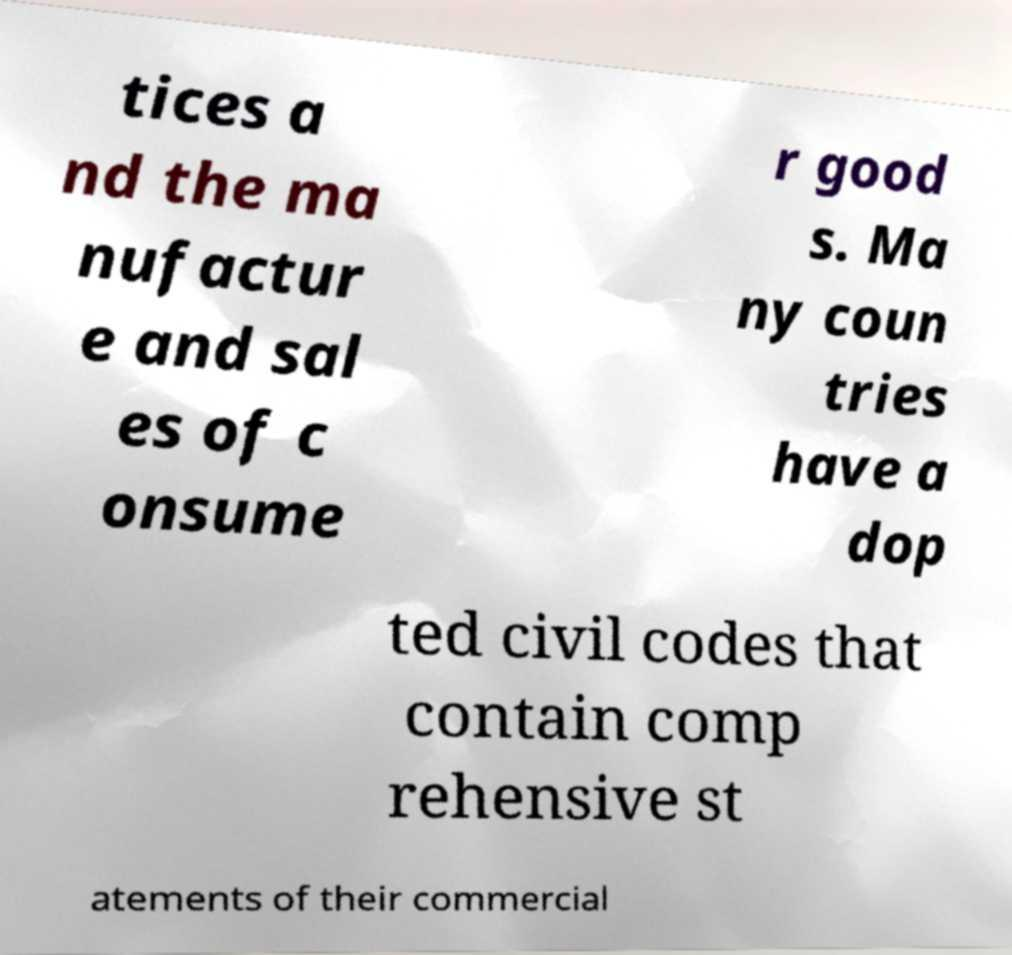I need the written content from this picture converted into text. Can you do that? tices a nd the ma nufactur e and sal es of c onsume r good s. Ma ny coun tries have a dop ted civil codes that contain comp rehensive st atements of their commercial 